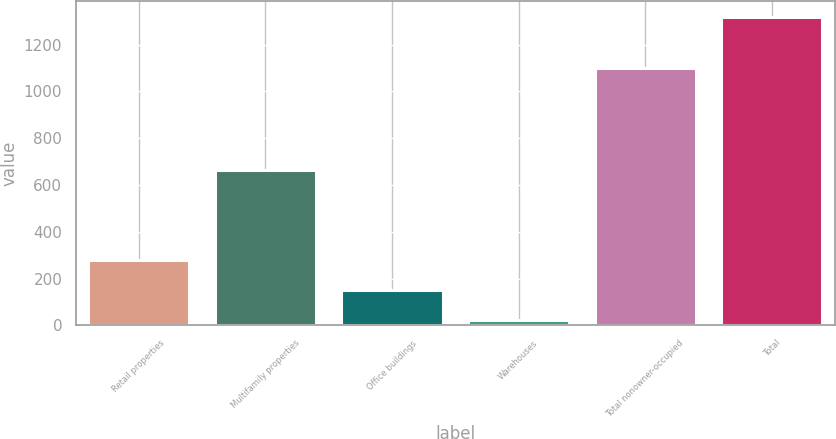Convert chart. <chart><loc_0><loc_0><loc_500><loc_500><bar_chart><fcel>Retail properties<fcel>Multifamily properties<fcel>Office buildings<fcel>Warehouses<fcel>Total nonowner-occupied<fcel>Total<nl><fcel>280.8<fcel>662<fcel>150.9<fcel>21<fcel>1098<fcel>1320<nl></chart> 